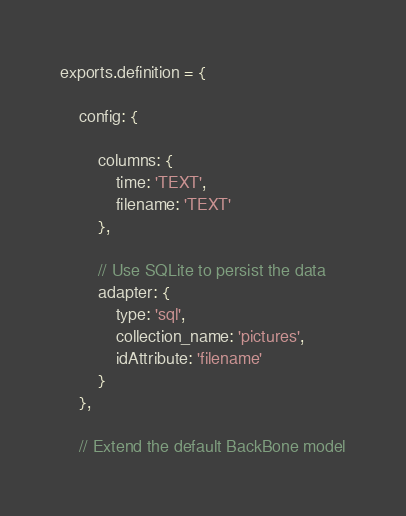<code> <loc_0><loc_0><loc_500><loc_500><_JavaScript_>exports.definition = {

    config: {

        columns: {
            time: 'TEXT',
            filename: 'TEXT'
        },

        // Use SQLite to persist the data
        adapter: {
            type: 'sql',
            collection_name: 'pictures',
            idAttribute: 'filename'
        }
    },

    // Extend the default BackBone model</code> 